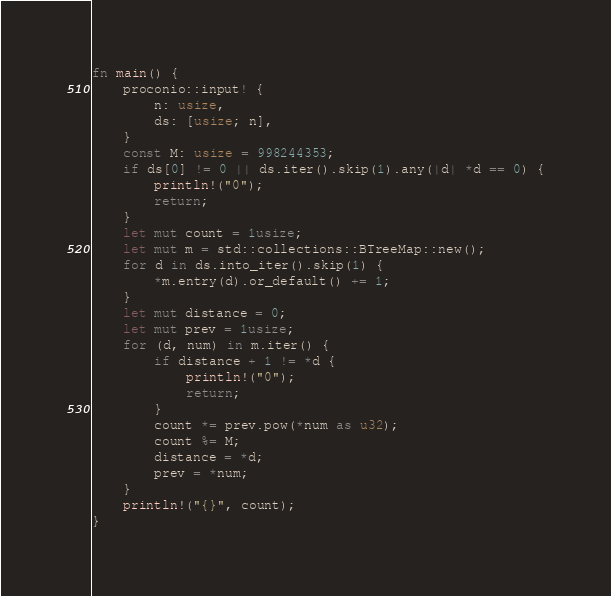<code> <loc_0><loc_0><loc_500><loc_500><_Rust_>fn main() {
    proconio::input! {
        n: usize,
        ds: [usize; n],
    }
    const M: usize = 998244353;
    if ds[0] != 0 || ds.iter().skip(1).any(|d| *d == 0) {
        println!("0");
        return;
    }
    let mut count = 1usize;
    let mut m = std::collections::BTreeMap::new();
    for d in ds.into_iter().skip(1) {
        *m.entry(d).or_default() += 1;
    }
    let mut distance = 0;
    let mut prev = 1usize;
    for (d, num) in m.iter() {
        if distance + 1 != *d {
            println!("0");
            return;
        }
        count *= prev.pow(*num as u32);
        count %= M;
        distance = *d;
        prev = *num;
    }
    println!("{}", count);
}
</code> 